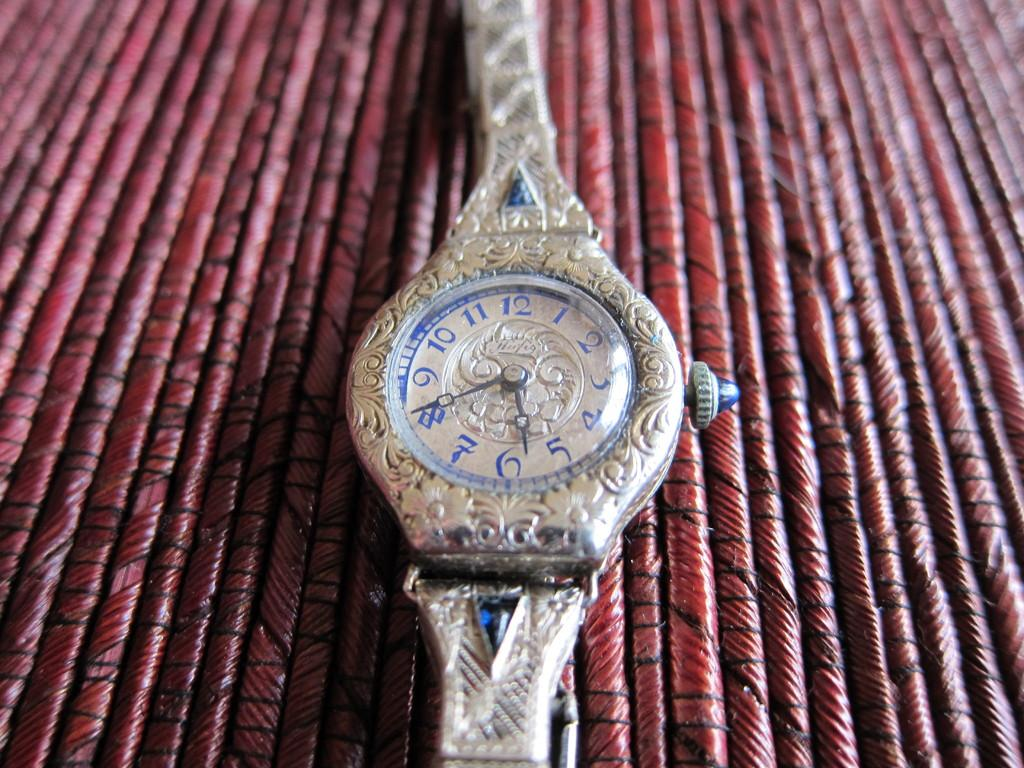<image>
Write a terse but informative summary of the picture. An antique silver watch with Arabic numerals and triangular blue gemstones inlaid at the top of both wrist bands. 